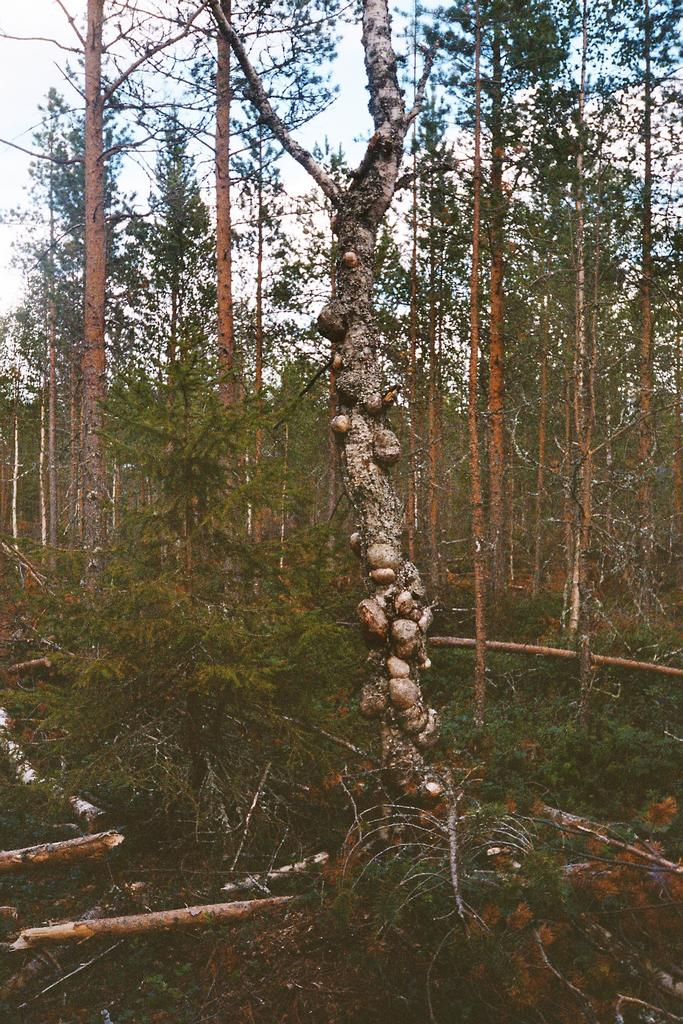What can be seen at the bottom of the image? There are cut down trees at the bottom of the image. What type of vegetation is present on the ground? Grass is present on the ground. What is visible in the background of the image? There are trees in the background of the image. What can be seen in the sky? There are clouds in the sky. What type of cracker is being handed out to the crowd in the image? There is no cracker or crowd present in the image; it features cut down trees, grass, trees in the background, and clouds in the sky. Are there any police officers visible in the image? There are no police officers present in the image. 